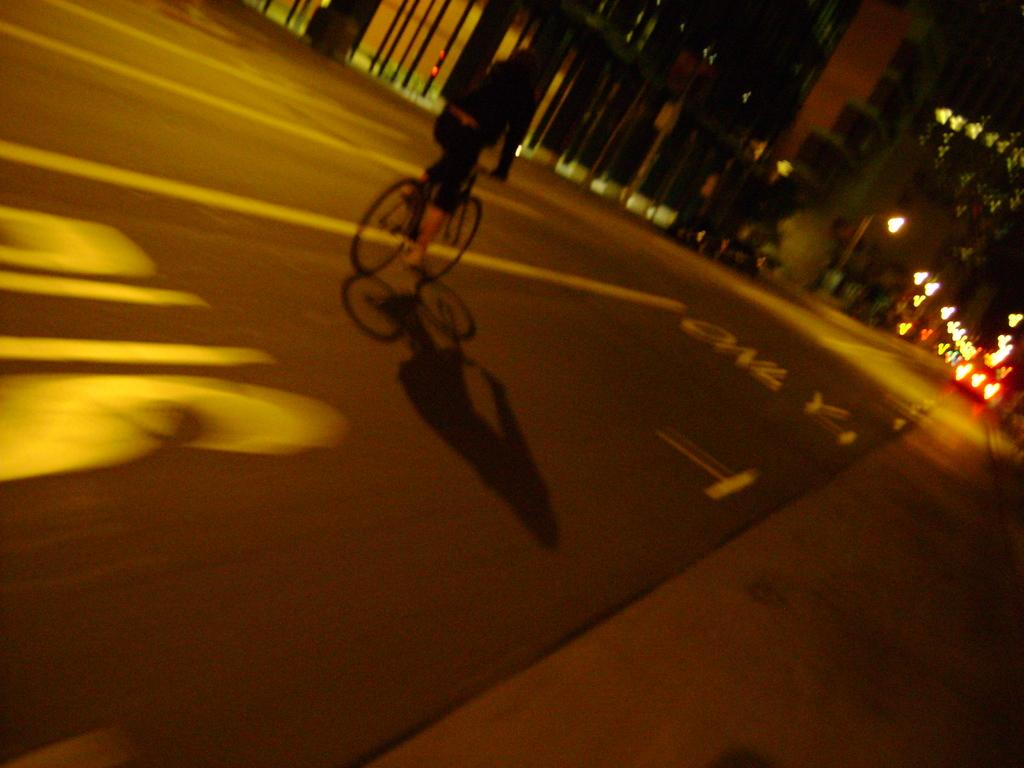What is the main subject of the image? There is a person in the image. What is the person doing in the image? The person is riding a bicycle. What type of surface can be seen beneath the person? There is ground visible in the image. What can be seen illuminating the scene in the image? There are lights in the image. What is present at the top of the image? There are a few objects at the top of the image. What type of snow can be seen falling in the image? There is no snow present in the image. How many mothers are visible in the image? There is no mention of a mother or any women in the image; it only features a person riding a bicycle. 